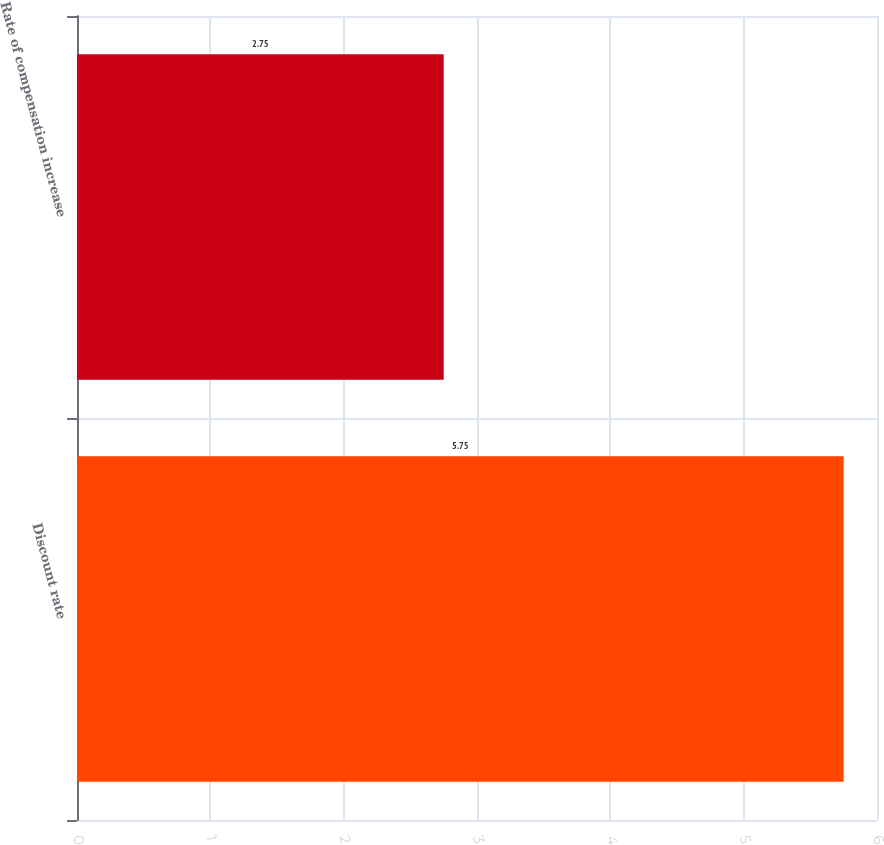Convert chart to OTSL. <chart><loc_0><loc_0><loc_500><loc_500><bar_chart><fcel>Discount rate<fcel>Rate of compensation increase<nl><fcel>5.75<fcel>2.75<nl></chart> 